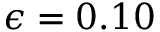<formula> <loc_0><loc_0><loc_500><loc_500>\epsilon = 0 . 1 0</formula> 